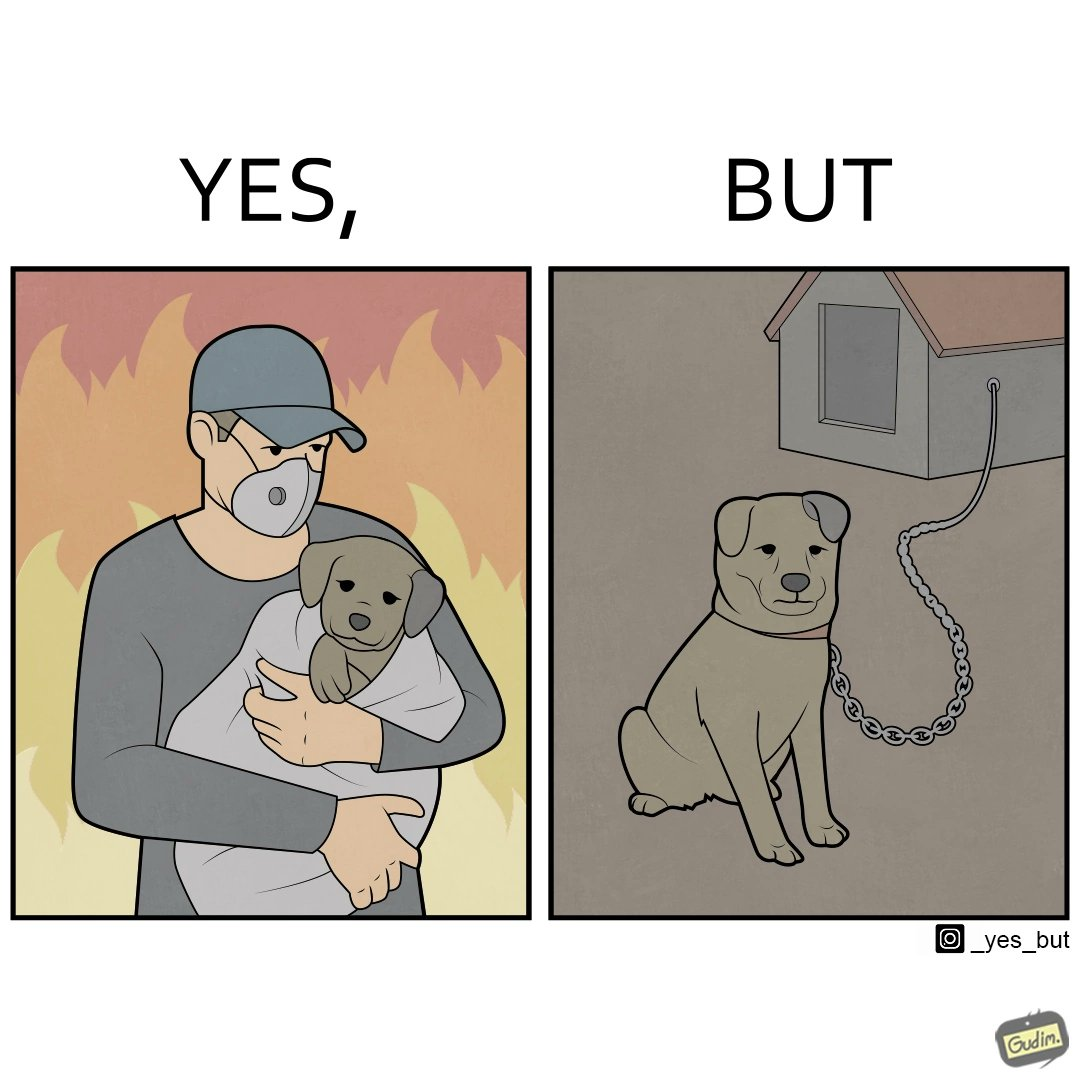Is there satirical content in this image? Yes, this image is satirical. 